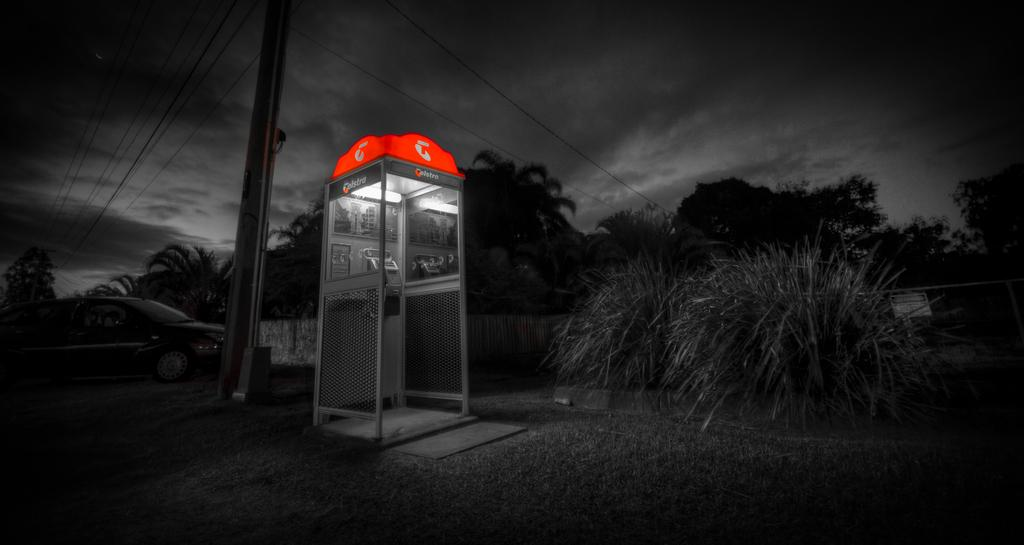What type of structure is present in the image? There is a booth in the image. What natural elements can be seen in the image? There are trees in the image. What else is present in the image besides the booth and trees? There is a pole with cables in the image. What can be seen in the background of the image? The sky is visible in the image. What language is being spoken by the people in the image? There are no people visible in the image, so it is not possible to determine what language they might be speaking. 